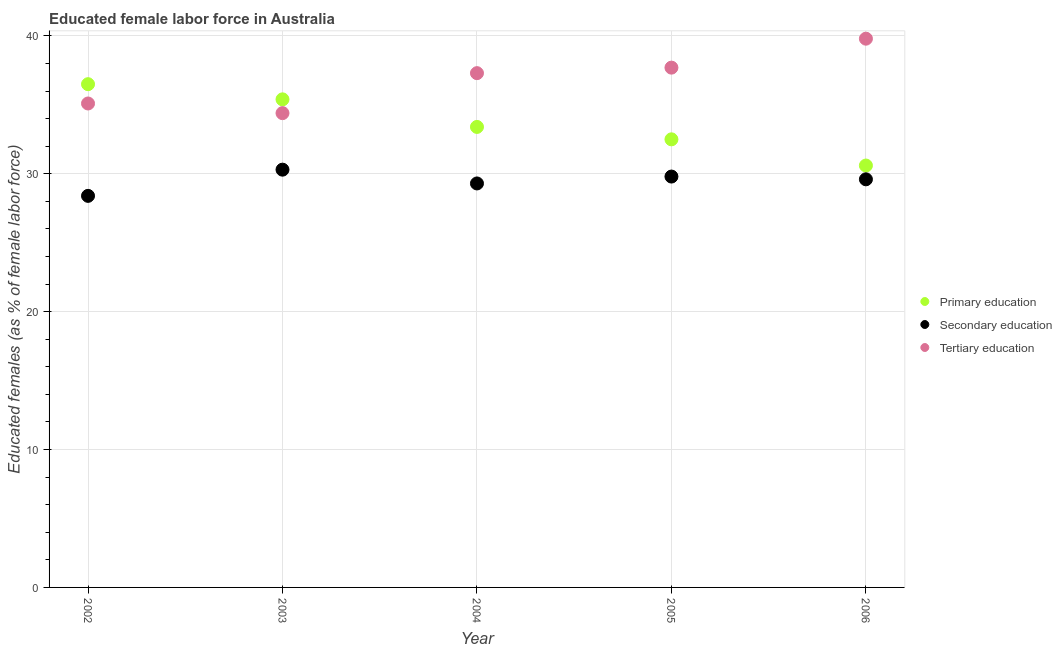How many different coloured dotlines are there?
Your answer should be very brief. 3. What is the percentage of female labor force who received primary education in 2002?
Your answer should be compact. 36.5. Across all years, what is the maximum percentage of female labor force who received tertiary education?
Your answer should be compact. 39.8. Across all years, what is the minimum percentage of female labor force who received primary education?
Your response must be concise. 30.6. In which year was the percentage of female labor force who received secondary education minimum?
Offer a very short reply. 2002. What is the total percentage of female labor force who received primary education in the graph?
Your response must be concise. 168.4. What is the difference between the percentage of female labor force who received primary education in 2003 and the percentage of female labor force who received secondary education in 2002?
Make the answer very short. 7. What is the average percentage of female labor force who received tertiary education per year?
Ensure brevity in your answer.  36.86. In the year 2004, what is the difference between the percentage of female labor force who received primary education and percentage of female labor force who received secondary education?
Your answer should be very brief. 4.1. What is the ratio of the percentage of female labor force who received primary education in 2004 to that in 2006?
Provide a short and direct response. 1.09. What is the difference between the highest and the second highest percentage of female labor force who received secondary education?
Your answer should be compact. 0.5. What is the difference between the highest and the lowest percentage of female labor force who received tertiary education?
Offer a terse response. 5.4. In how many years, is the percentage of female labor force who received primary education greater than the average percentage of female labor force who received primary education taken over all years?
Keep it short and to the point. 2. Is it the case that in every year, the sum of the percentage of female labor force who received primary education and percentage of female labor force who received secondary education is greater than the percentage of female labor force who received tertiary education?
Your answer should be compact. Yes. Is the percentage of female labor force who received tertiary education strictly less than the percentage of female labor force who received primary education over the years?
Offer a very short reply. No. How many dotlines are there?
Make the answer very short. 3. Are the values on the major ticks of Y-axis written in scientific E-notation?
Keep it short and to the point. No. Does the graph contain any zero values?
Keep it short and to the point. No. How many legend labels are there?
Make the answer very short. 3. What is the title of the graph?
Make the answer very short. Educated female labor force in Australia. Does "Poland" appear as one of the legend labels in the graph?
Give a very brief answer. No. What is the label or title of the X-axis?
Keep it short and to the point. Year. What is the label or title of the Y-axis?
Provide a succinct answer. Educated females (as % of female labor force). What is the Educated females (as % of female labor force) of Primary education in 2002?
Your answer should be compact. 36.5. What is the Educated females (as % of female labor force) in Secondary education in 2002?
Make the answer very short. 28.4. What is the Educated females (as % of female labor force) of Tertiary education in 2002?
Provide a succinct answer. 35.1. What is the Educated females (as % of female labor force) of Primary education in 2003?
Your answer should be compact. 35.4. What is the Educated females (as % of female labor force) in Secondary education in 2003?
Provide a succinct answer. 30.3. What is the Educated females (as % of female labor force) in Tertiary education in 2003?
Make the answer very short. 34.4. What is the Educated females (as % of female labor force) of Primary education in 2004?
Your answer should be compact. 33.4. What is the Educated females (as % of female labor force) of Secondary education in 2004?
Offer a very short reply. 29.3. What is the Educated females (as % of female labor force) in Tertiary education in 2004?
Keep it short and to the point. 37.3. What is the Educated females (as % of female labor force) of Primary education in 2005?
Make the answer very short. 32.5. What is the Educated females (as % of female labor force) of Secondary education in 2005?
Keep it short and to the point. 29.8. What is the Educated females (as % of female labor force) of Tertiary education in 2005?
Your answer should be compact. 37.7. What is the Educated females (as % of female labor force) of Primary education in 2006?
Provide a succinct answer. 30.6. What is the Educated females (as % of female labor force) of Secondary education in 2006?
Provide a succinct answer. 29.6. What is the Educated females (as % of female labor force) in Tertiary education in 2006?
Offer a terse response. 39.8. Across all years, what is the maximum Educated females (as % of female labor force) in Primary education?
Your response must be concise. 36.5. Across all years, what is the maximum Educated females (as % of female labor force) in Secondary education?
Make the answer very short. 30.3. Across all years, what is the maximum Educated females (as % of female labor force) in Tertiary education?
Your response must be concise. 39.8. Across all years, what is the minimum Educated females (as % of female labor force) in Primary education?
Ensure brevity in your answer.  30.6. Across all years, what is the minimum Educated females (as % of female labor force) of Secondary education?
Provide a succinct answer. 28.4. Across all years, what is the minimum Educated females (as % of female labor force) of Tertiary education?
Make the answer very short. 34.4. What is the total Educated females (as % of female labor force) of Primary education in the graph?
Your response must be concise. 168.4. What is the total Educated females (as % of female labor force) of Secondary education in the graph?
Your answer should be compact. 147.4. What is the total Educated females (as % of female labor force) in Tertiary education in the graph?
Your answer should be very brief. 184.3. What is the difference between the Educated females (as % of female labor force) in Primary education in 2002 and that in 2003?
Provide a succinct answer. 1.1. What is the difference between the Educated females (as % of female labor force) in Primary education in 2002 and that in 2004?
Keep it short and to the point. 3.1. What is the difference between the Educated females (as % of female labor force) in Primary education in 2002 and that in 2005?
Give a very brief answer. 4. What is the difference between the Educated females (as % of female labor force) of Secondary education in 2002 and that in 2005?
Keep it short and to the point. -1.4. What is the difference between the Educated females (as % of female labor force) of Tertiary education in 2002 and that in 2005?
Ensure brevity in your answer.  -2.6. What is the difference between the Educated females (as % of female labor force) of Primary education in 2002 and that in 2006?
Give a very brief answer. 5.9. What is the difference between the Educated females (as % of female labor force) of Tertiary education in 2002 and that in 2006?
Your response must be concise. -4.7. What is the difference between the Educated females (as % of female labor force) of Primary education in 2003 and that in 2004?
Keep it short and to the point. 2. What is the difference between the Educated females (as % of female labor force) in Secondary education in 2003 and that in 2004?
Provide a succinct answer. 1. What is the difference between the Educated females (as % of female labor force) in Primary education in 2003 and that in 2005?
Give a very brief answer. 2.9. What is the difference between the Educated females (as % of female labor force) in Secondary education in 2003 and that in 2005?
Your answer should be compact. 0.5. What is the difference between the Educated females (as % of female labor force) of Primary education in 2003 and that in 2006?
Keep it short and to the point. 4.8. What is the difference between the Educated females (as % of female labor force) of Secondary education in 2003 and that in 2006?
Keep it short and to the point. 0.7. What is the difference between the Educated females (as % of female labor force) of Tertiary education in 2003 and that in 2006?
Provide a short and direct response. -5.4. What is the difference between the Educated females (as % of female labor force) of Secondary education in 2004 and that in 2005?
Keep it short and to the point. -0.5. What is the difference between the Educated females (as % of female labor force) of Primary education in 2004 and that in 2006?
Your answer should be compact. 2.8. What is the difference between the Educated females (as % of female labor force) of Tertiary education in 2005 and that in 2006?
Offer a terse response. -2.1. What is the difference between the Educated females (as % of female labor force) of Primary education in 2002 and the Educated females (as % of female labor force) of Secondary education in 2003?
Offer a very short reply. 6.2. What is the difference between the Educated females (as % of female labor force) of Primary education in 2002 and the Educated females (as % of female labor force) of Tertiary education in 2003?
Make the answer very short. 2.1. What is the difference between the Educated females (as % of female labor force) in Secondary education in 2002 and the Educated females (as % of female labor force) in Tertiary education in 2003?
Ensure brevity in your answer.  -6. What is the difference between the Educated females (as % of female labor force) of Primary education in 2002 and the Educated females (as % of female labor force) of Secondary education in 2004?
Your response must be concise. 7.2. What is the difference between the Educated females (as % of female labor force) in Primary education in 2002 and the Educated females (as % of female labor force) in Tertiary education in 2004?
Make the answer very short. -0.8. What is the difference between the Educated females (as % of female labor force) of Secondary education in 2002 and the Educated females (as % of female labor force) of Tertiary education in 2004?
Offer a terse response. -8.9. What is the difference between the Educated females (as % of female labor force) in Primary education in 2002 and the Educated females (as % of female labor force) in Tertiary education in 2005?
Offer a very short reply. -1.2. What is the difference between the Educated females (as % of female labor force) in Primary education in 2002 and the Educated females (as % of female labor force) in Secondary education in 2006?
Keep it short and to the point. 6.9. What is the difference between the Educated females (as % of female labor force) of Secondary education in 2002 and the Educated females (as % of female labor force) of Tertiary education in 2006?
Give a very brief answer. -11.4. What is the difference between the Educated females (as % of female labor force) of Primary education in 2003 and the Educated females (as % of female labor force) of Secondary education in 2004?
Your answer should be compact. 6.1. What is the difference between the Educated females (as % of female labor force) of Secondary education in 2003 and the Educated females (as % of female labor force) of Tertiary education in 2004?
Your response must be concise. -7. What is the difference between the Educated females (as % of female labor force) of Secondary education in 2003 and the Educated females (as % of female labor force) of Tertiary education in 2005?
Make the answer very short. -7.4. What is the difference between the Educated females (as % of female labor force) of Primary education in 2004 and the Educated females (as % of female labor force) of Secondary education in 2005?
Your answer should be very brief. 3.6. What is the difference between the Educated females (as % of female labor force) in Secondary education in 2004 and the Educated females (as % of female labor force) in Tertiary education in 2006?
Offer a very short reply. -10.5. What is the difference between the Educated females (as % of female labor force) in Secondary education in 2005 and the Educated females (as % of female labor force) in Tertiary education in 2006?
Ensure brevity in your answer.  -10. What is the average Educated females (as % of female labor force) of Primary education per year?
Your response must be concise. 33.68. What is the average Educated females (as % of female labor force) in Secondary education per year?
Your answer should be compact. 29.48. What is the average Educated females (as % of female labor force) in Tertiary education per year?
Offer a very short reply. 36.86. In the year 2002, what is the difference between the Educated females (as % of female labor force) in Primary education and Educated females (as % of female labor force) in Secondary education?
Ensure brevity in your answer.  8.1. In the year 2002, what is the difference between the Educated females (as % of female labor force) of Primary education and Educated females (as % of female labor force) of Tertiary education?
Provide a short and direct response. 1.4. In the year 2002, what is the difference between the Educated females (as % of female labor force) of Secondary education and Educated females (as % of female labor force) of Tertiary education?
Keep it short and to the point. -6.7. In the year 2003, what is the difference between the Educated females (as % of female labor force) in Primary education and Educated females (as % of female labor force) in Secondary education?
Your answer should be very brief. 5.1. In the year 2003, what is the difference between the Educated females (as % of female labor force) in Secondary education and Educated females (as % of female labor force) in Tertiary education?
Keep it short and to the point. -4.1. In the year 2004, what is the difference between the Educated females (as % of female labor force) of Primary education and Educated females (as % of female labor force) of Secondary education?
Offer a very short reply. 4.1. In the year 2004, what is the difference between the Educated females (as % of female labor force) in Secondary education and Educated females (as % of female labor force) in Tertiary education?
Provide a succinct answer. -8. In the year 2005, what is the difference between the Educated females (as % of female labor force) of Primary education and Educated females (as % of female labor force) of Tertiary education?
Your answer should be compact. -5.2. In the year 2005, what is the difference between the Educated females (as % of female labor force) of Secondary education and Educated females (as % of female labor force) of Tertiary education?
Your answer should be very brief. -7.9. In the year 2006, what is the difference between the Educated females (as % of female labor force) of Primary education and Educated females (as % of female labor force) of Secondary education?
Your answer should be very brief. 1. In the year 2006, what is the difference between the Educated females (as % of female labor force) of Primary education and Educated females (as % of female labor force) of Tertiary education?
Your answer should be very brief. -9.2. In the year 2006, what is the difference between the Educated females (as % of female labor force) of Secondary education and Educated females (as % of female labor force) of Tertiary education?
Your response must be concise. -10.2. What is the ratio of the Educated females (as % of female labor force) of Primary education in 2002 to that in 2003?
Provide a short and direct response. 1.03. What is the ratio of the Educated females (as % of female labor force) in Secondary education in 2002 to that in 2003?
Provide a succinct answer. 0.94. What is the ratio of the Educated females (as % of female labor force) of Tertiary education in 2002 to that in 2003?
Ensure brevity in your answer.  1.02. What is the ratio of the Educated females (as % of female labor force) of Primary education in 2002 to that in 2004?
Your answer should be very brief. 1.09. What is the ratio of the Educated females (as % of female labor force) of Secondary education in 2002 to that in 2004?
Make the answer very short. 0.97. What is the ratio of the Educated females (as % of female labor force) in Tertiary education in 2002 to that in 2004?
Your answer should be very brief. 0.94. What is the ratio of the Educated females (as % of female labor force) in Primary education in 2002 to that in 2005?
Your response must be concise. 1.12. What is the ratio of the Educated females (as % of female labor force) in Secondary education in 2002 to that in 2005?
Keep it short and to the point. 0.95. What is the ratio of the Educated females (as % of female labor force) in Tertiary education in 2002 to that in 2005?
Offer a terse response. 0.93. What is the ratio of the Educated females (as % of female labor force) in Primary education in 2002 to that in 2006?
Offer a terse response. 1.19. What is the ratio of the Educated females (as % of female labor force) in Secondary education in 2002 to that in 2006?
Provide a succinct answer. 0.96. What is the ratio of the Educated females (as % of female labor force) of Tertiary education in 2002 to that in 2006?
Your answer should be compact. 0.88. What is the ratio of the Educated females (as % of female labor force) of Primary education in 2003 to that in 2004?
Provide a succinct answer. 1.06. What is the ratio of the Educated females (as % of female labor force) of Secondary education in 2003 to that in 2004?
Provide a succinct answer. 1.03. What is the ratio of the Educated females (as % of female labor force) in Tertiary education in 2003 to that in 2004?
Your answer should be very brief. 0.92. What is the ratio of the Educated females (as % of female labor force) of Primary education in 2003 to that in 2005?
Make the answer very short. 1.09. What is the ratio of the Educated females (as % of female labor force) in Secondary education in 2003 to that in 2005?
Make the answer very short. 1.02. What is the ratio of the Educated females (as % of female labor force) in Tertiary education in 2003 to that in 2005?
Your response must be concise. 0.91. What is the ratio of the Educated females (as % of female labor force) of Primary education in 2003 to that in 2006?
Provide a succinct answer. 1.16. What is the ratio of the Educated females (as % of female labor force) in Secondary education in 2003 to that in 2006?
Provide a succinct answer. 1.02. What is the ratio of the Educated females (as % of female labor force) in Tertiary education in 2003 to that in 2006?
Your response must be concise. 0.86. What is the ratio of the Educated females (as % of female labor force) in Primary education in 2004 to that in 2005?
Ensure brevity in your answer.  1.03. What is the ratio of the Educated females (as % of female labor force) in Secondary education in 2004 to that in 2005?
Give a very brief answer. 0.98. What is the ratio of the Educated females (as % of female labor force) in Tertiary education in 2004 to that in 2005?
Make the answer very short. 0.99. What is the ratio of the Educated females (as % of female labor force) in Primary education in 2004 to that in 2006?
Ensure brevity in your answer.  1.09. What is the ratio of the Educated females (as % of female labor force) in Secondary education in 2004 to that in 2006?
Ensure brevity in your answer.  0.99. What is the ratio of the Educated females (as % of female labor force) of Tertiary education in 2004 to that in 2006?
Offer a terse response. 0.94. What is the ratio of the Educated females (as % of female labor force) in Primary education in 2005 to that in 2006?
Your answer should be very brief. 1.06. What is the ratio of the Educated females (as % of female labor force) in Secondary education in 2005 to that in 2006?
Keep it short and to the point. 1.01. What is the ratio of the Educated females (as % of female labor force) in Tertiary education in 2005 to that in 2006?
Keep it short and to the point. 0.95. What is the difference between the highest and the second highest Educated females (as % of female labor force) in Secondary education?
Give a very brief answer. 0.5. What is the difference between the highest and the lowest Educated females (as % of female labor force) in Secondary education?
Give a very brief answer. 1.9. 